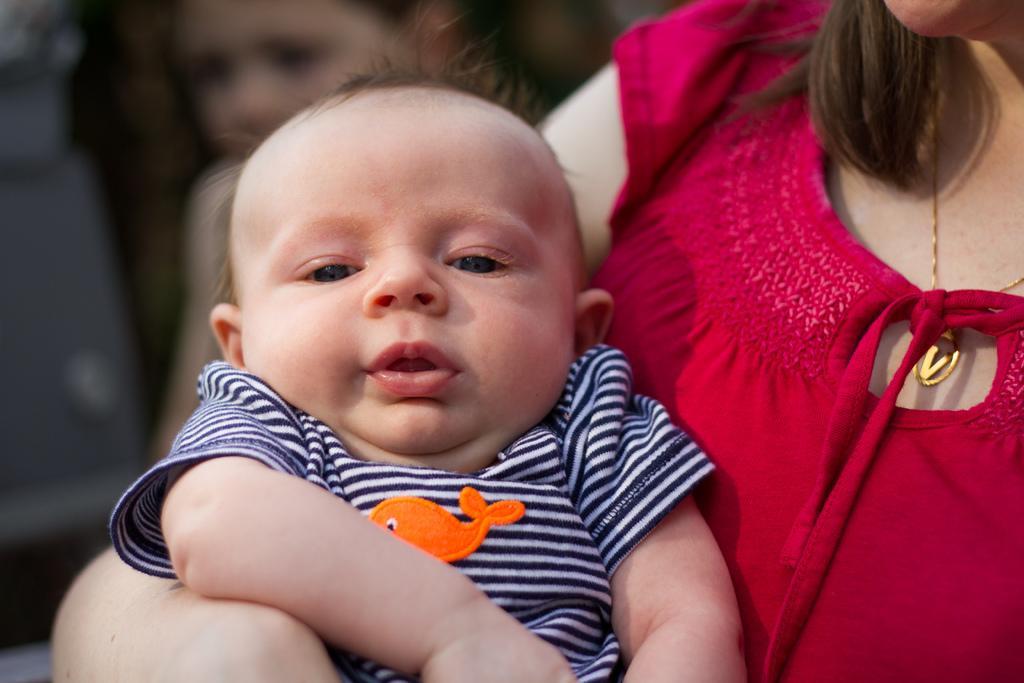Can you describe this image briefly? There is one woman wearing a red color dress is holding a baby as we can see in the middle of this image, and there is one other person in the background. 